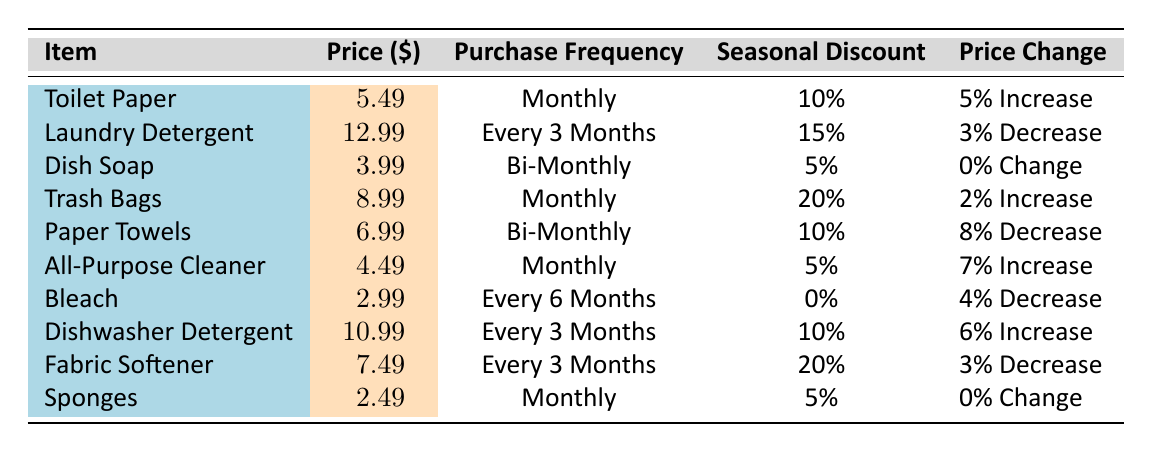What is the price of Toilet Paper? The table directly lists the price of Toilet Paper in the corresponding row, which indicates that it is 5.49.
Answer: 5.49 How often do you purchase Bleach? The frequency of purchase for Bleach is specified in the table, which states that it is purchased every 6 months.
Answer: Every 6 months Is there a seasonal discount for Dish Soap? The table indicates that there is a seasonal discount listed for Dish Soap as 5%. Hence, the answer is yes.
Answer: Yes What item has the highest price change percentage last year? By examining the price changes in the table, the item with the highest price change percentage is Paper Towels with an 8% decrease, making it the most significant change.
Answer: Paper Towels What is the average price of items purchased monthly? The items purchased monthly are Toilet Paper (5.49), Trash Bags (8.99), All-Purpose Cleaner (4.49), and Sponges (2.49). First, we find the total: 5.49 + 8.99 + 4.49 + 2.49 = 21.46 and divide by the number of items (4) to get the average price, which is 21.46 / 4 = 5.365.
Answer: 5.37 Does Laundry Detergent have a seasonal discount greater than 15%? According to the table, Laundry Detergent has a seasonal discount of 15%, which means it does not exceed that percentage.
Answer: No What is the total percentage increase in price for items that have reported an increase last year? From the table, there are three items with price increases: Toilet Paper (5%), Trash Bags (2%), and All-Purpose Cleaner (7%). Adding these gives a total increase of 5% + 2% + 7% = 14%.
Answer: 14% Which item has the lowest price? In the price column, the lowest price listed is for Sponges, which is 2.49.
Answer: Sponges What is the frequency of purchase for Fabric Softener? The frequency of purchase for Fabric Softener is explicitly stated in the table as every three months.
Answer: Every 3 months 